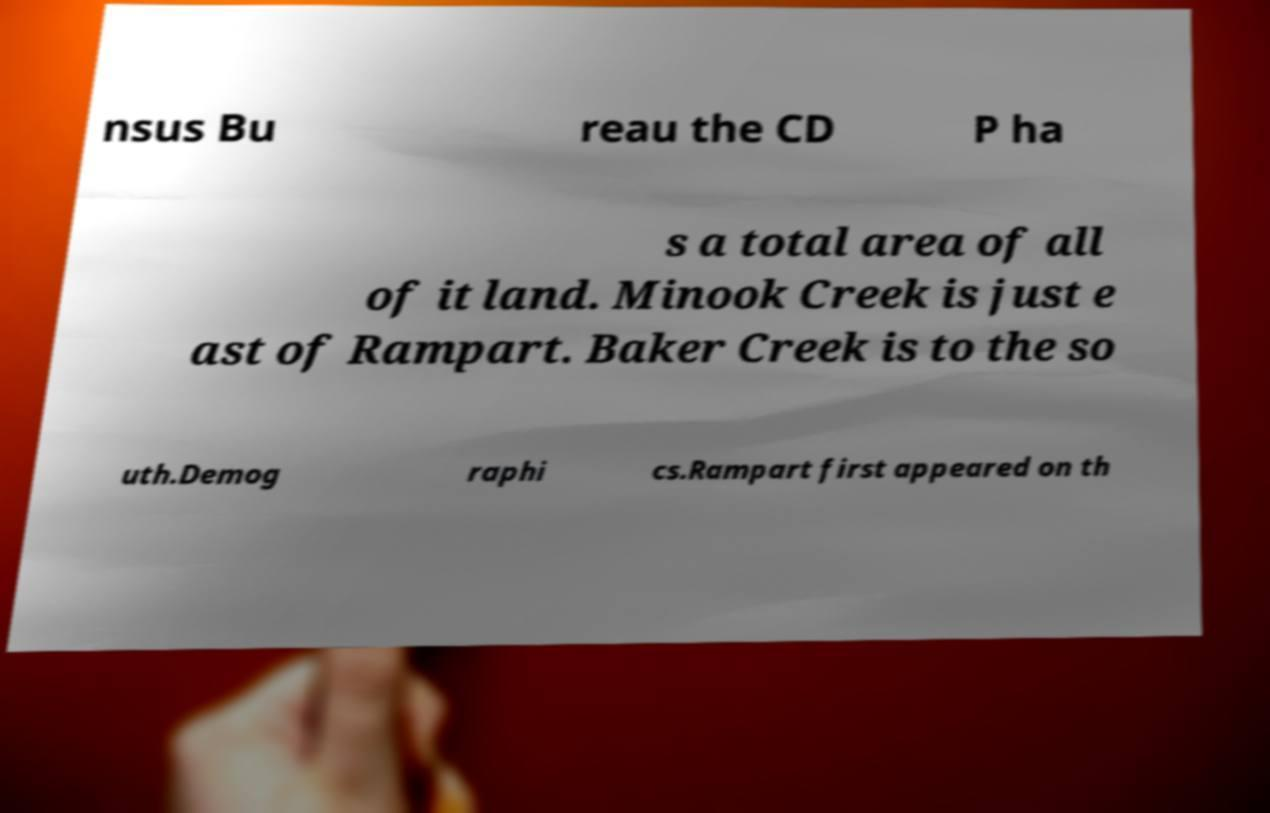What messages or text are displayed in this image? I need them in a readable, typed format. nsus Bu reau the CD P ha s a total area of all of it land. Minook Creek is just e ast of Rampart. Baker Creek is to the so uth.Demog raphi cs.Rampart first appeared on th 